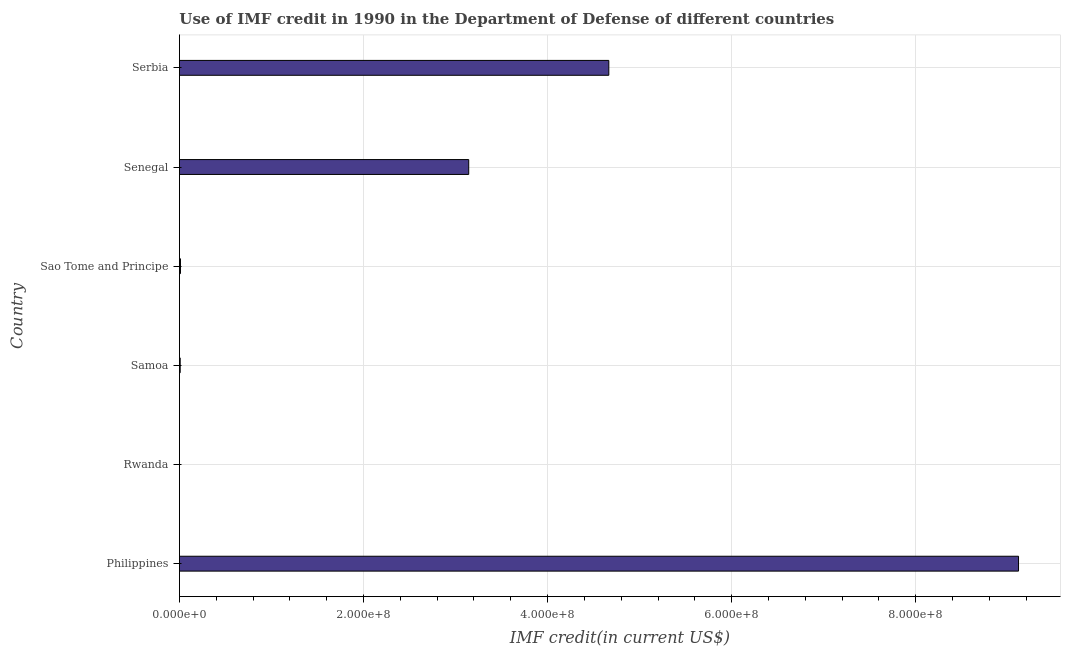What is the title of the graph?
Make the answer very short. Use of IMF credit in 1990 in the Department of Defense of different countries. What is the label or title of the X-axis?
Ensure brevity in your answer.  IMF credit(in current US$). What is the use of imf credit in dod in Serbia?
Provide a succinct answer. 4.67e+08. Across all countries, what is the maximum use of imf credit in dod?
Your answer should be compact. 9.12e+08. Across all countries, what is the minimum use of imf credit in dod?
Offer a terse response. 1.01e+05. In which country was the use of imf credit in dod minimum?
Your response must be concise. Rwanda. What is the sum of the use of imf credit in dod?
Provide a short and direct response. 1.69e+09. What is the difference between the use of imf credit in dod in Sao Tome and Principe and Senegal?
Give a very brief answer. -3.13e+08. What is the average use of imf credit in dod per country?
Keep it short and to the point. 2.82e+08. What is the median use of imf credit in dod?
Give a very brief answer. 1.58e+08. In how many countries, is the use of imf credit in dod greater than 200000000 US$?
Ensure brevity in your answer.  3. What is the ratio of the use of imf credit in dod in Sao Tome and Principe to that in Serbia?
Offer a terse response. 0. Is the use of imf credit in dod in Sao Tome and Principe less than that in Serbia?
Your response must be concise. Yes. Is the difference between the use of imf credit in dod in Senegal and Serbia greater than the difference between any two countries?
Give a very brief answer. No. What is the difference between the highest and the second highest use of imf credit in dod?
Provide a succinct answer. 4.45e+08. What is the difference between the highest and the lowest use of imf credit in dod?
Your answer should be very brief. 9.12e+08. In how many countries, is the use of imf credit in dod greater than the average use of imf credit in dod taken over all countries?
Keep it short and to the point. 3. What is the IMF credit(in current US$) in Philippines?
Ensure brevity in your answer.  9.12e+08. What is the IMF credit(in current US$) in Rwanda?
Provide a succinct answer. 1.01e+05. What is the IMF credit(in current US$) in Samoa?
Offer a very short reply. 8.35e+05. What is the IMF credit(in current US$) in Sao Tome and Principe?
Offer a terse response. 1.14e+06. What is the IMF credit(in current US$) of Senegal?
Make the answer very short. 3.14e+08. What is the IMF credit(in current US$) of Serbia?
Give a very brief answer. 4.67e+08. What is the difference between the IMF credit(in current US$) in Philippines and Rwanda?
Provide a succinct answer. 9.12e+08. What is the difference between the IMF credit(in current US$) in Philippines and Samoa?
Ensure brevity in your answer.  9.11e+08. What is the difference between the IMF credit(in current US$) in Philippines and Sao Tome and Principe?
Your response must be concise. 9.11e+08. What is the difference between the IMF credit(in current US$) in Philippines and Senegal?
Make the answer very short. 5.97e+08. What is the difference between the IMF credit(in current US$) in Philippines and Serbia?
Your answer should be very brief. 4.45e+08. What is the difference between the IMF credit(in current US$) in Rwanda and Samoa?
Your response must be concise. -7.34e+05. What is the difference between the IMF credit(in current US$) in Rwanda and Sao Tome and Principe?
Your response must be concise. -1.04e+06. What is the difference between the IMF credit(in current US$) in Rwanda and Senegal?
Make the answer very short. -3.14e+08. What is the difference between the IMF credit(in current US$) in Rwanda and Serbia?
Your answer should be compact. -4.66e+08. What is the difference between the IMF credit(in current US$) in Samoa and Sao Tome and Principe?
Offer a terse response. -3.03e+05. What is the difference between the IMF credit(in current US$) in Samoa and Senegal?
Give a very brief answer. -3.14e+08. What is the difference between the IMF credit(in current US$) in Samoa and Serbia?
Your response must be concise. -4.66e+08. What is the difference between the IMF credit(in current US$) in Sao Tome and Principe and Senegal?
Ensure brevity in your answer.  -3.13e+08. What is the difference between the IMF credit(in current US$) in Sao Tome and Principe and Serbia?
Your response must be concise. -4.65e+08. What is the difference between the IMF credit(in current US$) in Senegal and Serbia?
Your answer should be very brief. -1.52e+08. What is the ratio of the IMF credit(in current US$) in Philippines to that in Rwanda?
Your response must be concise. 9027.1. What is the ratio of the IMF credit(in current US$) in Philippines to that in Samoa?
Offer a terse response. 1091.9. What is the ratio of the IMF credit(in current US$) in Philippines to that in Sao Tome and Principe?
Provide a succinct answer. 801.17. What is the ratio of the IMF credit(in current US$) in Philippines to that in Senegal?
Provide a short and direct response. 2.9. What is the ratio of the IMF credit(in current US$) in Philippines to that in Serbia?
Provide a succinct answer. 1.95. What is the ratio of the IMF credit(in current US$) in Rwanda to that in Samoa?
Make the answer very short. 0.12. What is the ratio of the IMF credit(in current US$) in Rwanda to that in Sao Tome and Principe?
Your response must be concise. 0.09. What is the ratio of the IMF credit(in current US$) in Rwanda to that in Senegal?
Your answer should be very brief. 0. What is the ratio of the IMF credit(in current US$) in Samoa to that in Sao Tome and Principe?
Your response must be concise. 0.73. What is the ratio of the IMF credit(in current US$) in Samoa to that in Senegal?
Give a very brief answer. 0. What is the ratio of the IMF credit(in current US$) in Samoa to that in Serbia?
Provide a succinct answer. 0. What is the ratio of the IMF credit(in current US$) in Sao Tome and Principe to that in Senegal?
Give a very brief answer. 0. What is the ratio of the IMF credit(in current US$) in Sao Tome and Principe to that in Serbia?
Make the answer very short. 0. What is the ratio of the IMF credit(in current US$) in Senegal to that in Serbia?
Keep it short and to the point. 0.67. 